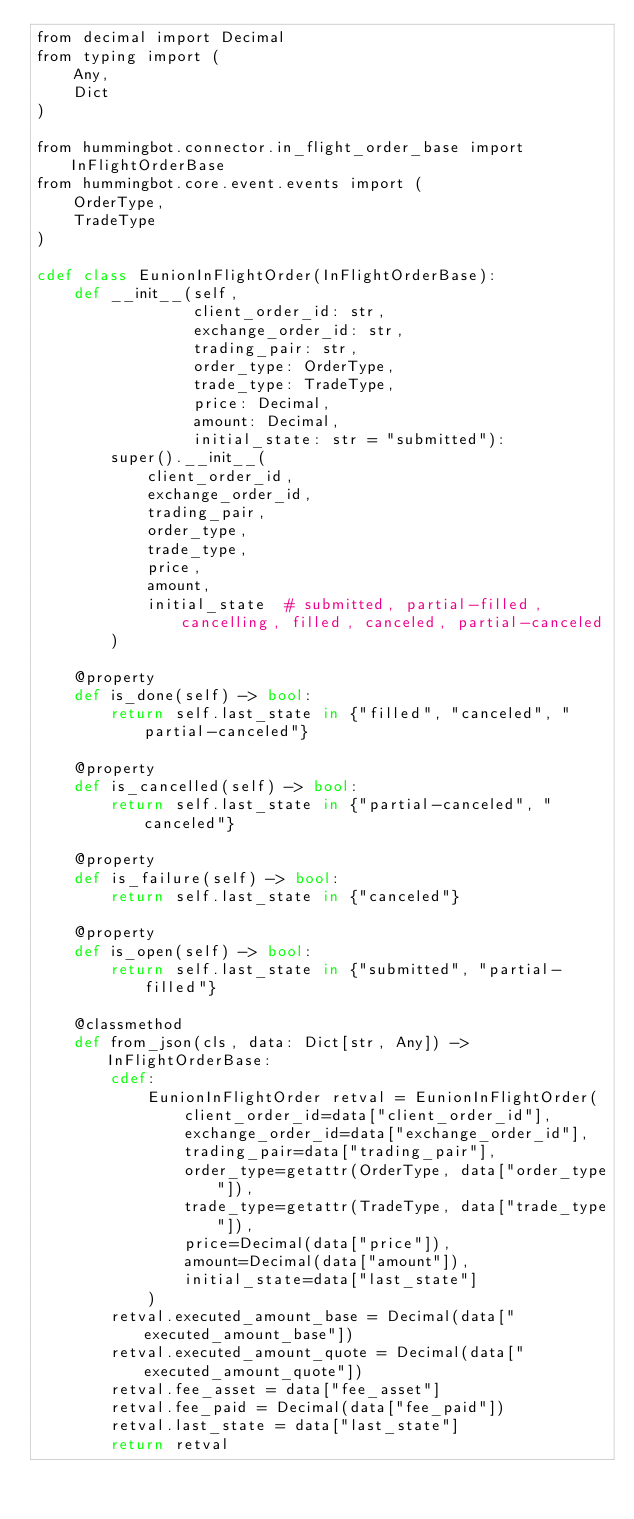Convert code to text. <code><loc_0><loc_0><loc_500><loc_500><_Cython_>from decimal import Decimal
from typing import (
    Any,
    Dict
)

from hummingbot.connector.in_flight_order_base import InFlightOrderBase
from hummingbot.core.event.events import (
    OrderType,
    TradeType
)

cdef class EunionInFlightOrder(InFlightOrderBase):
    def __init__(self,
                 client_order_id: str,
                 exchange_order_id: str,
                 trading_pair: str,
                 order_type: OrderType,
                 trade_type: TradeType,
                 price: Decimal,
                 amount: Decimal,
                 initial_state: str = "submitted"):
        super().__init__(
            client_order_id,
            exchange_order_id,
            trading_pair,
            order_type,
            trade_type,
            price,
            amount,
            initial_state  # submitted, partial-filled, cancelling, filled, canceled, partial-canceled
        )

    @property
    def is_done(self) -> bool:
        return self.last_state in {"filled", "canceled", "partial-canceled"}

    @property
    def is_cancelled(self) -> bool:
        return self.last_state in {"partial-canceled", "canceled"}

    @property
    def is_failure(self) -> bool:
        return self.last_state in {"canceled"}

    @property
    def is_open(self) -> bool:
        return self.last_state in {"submitted", "partial-filled"}

    @classmethod
    def from_json(cls, data: Dict[str, Any]) -> InFlightOrderBase:
        cdef:
            EunionInFlightOrder retval = EunionInFlightOrder(
                client_order_id=data["client_order_id"],
                exchange_order_id=data["exchange_order_id"],
                trading_pair=data["trading_pair"],
                order_type=getattr(OrderType, data["order_type"]),
                trade_type=getattr(TradeType, data["trade_type"]),
                price=Decimal(data["price"]),
                amount=Decimal(data["amount"]),
                initial_state=data["last_state"]
            )
        retval.executed_amount_base = Decimal(data["executed_amount_base"])
        retval.executed_amount_quote = Decimal(data["executed_amount_quote"])
        retval.fee_asset = data["fee_asset"]
        retval.fee_paid = Decimal(data["fee_paid"])
        retval.last_state = data["last_state"]
        return retval
</code> 